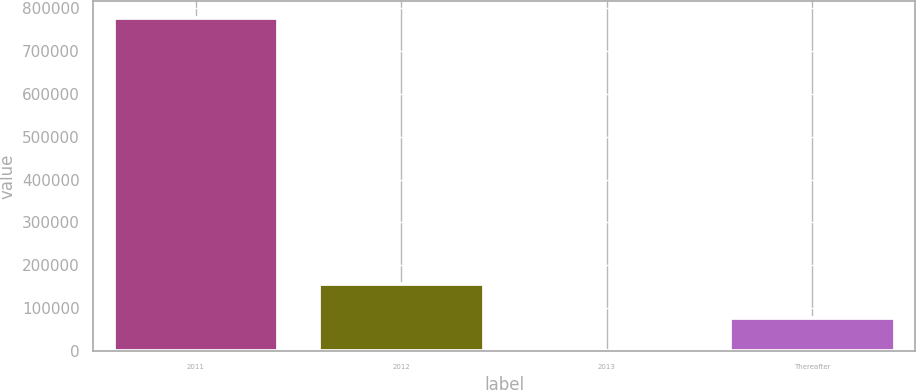Convert chart. <chart><loc_0><loc_0><loc_500><loc_500><bar_chart><fcel>2011<fcel>2012<fcel>2013<fcel>Thereafter<nl><fcel>777241<fcel>155472<fcel>30<fcel>77751.1<nl></chart> 